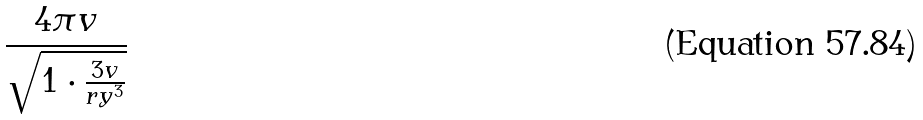Convert formula to latex. <formula><loc_0><loc_0><loc_500><loc_500>\frac { 4 \pi v } { \sqrt { 1 \cdot \frac { 3 v } { r y ^ { 3 } } } }</formula> 